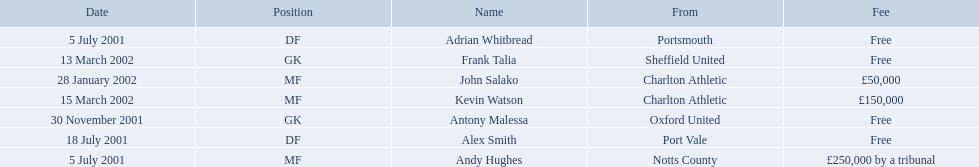What are the names of all the players? Andy Hughes, Adrian Whitbread, Alex Smith, Antony Malessa, John Salako, Frank Talia, Kevin Watson. What fee did andy hughes command? £250,000 by a tribunal. What fee did john salako command? £50,000. Which player had the highest fee, andy hughes or john salako? Andy Hughes. What are all of the names? Andy Hughes, Adrian Whitbread, Alex Smith, Antony Malessa, John Salako, Frank Talia, Kevin Watson. What was the fee for each person? £250,000 by a tribunal, Free, Free, Free, £50,000, Free, £150,000. And who had the highest fee? Andy Hughes. 